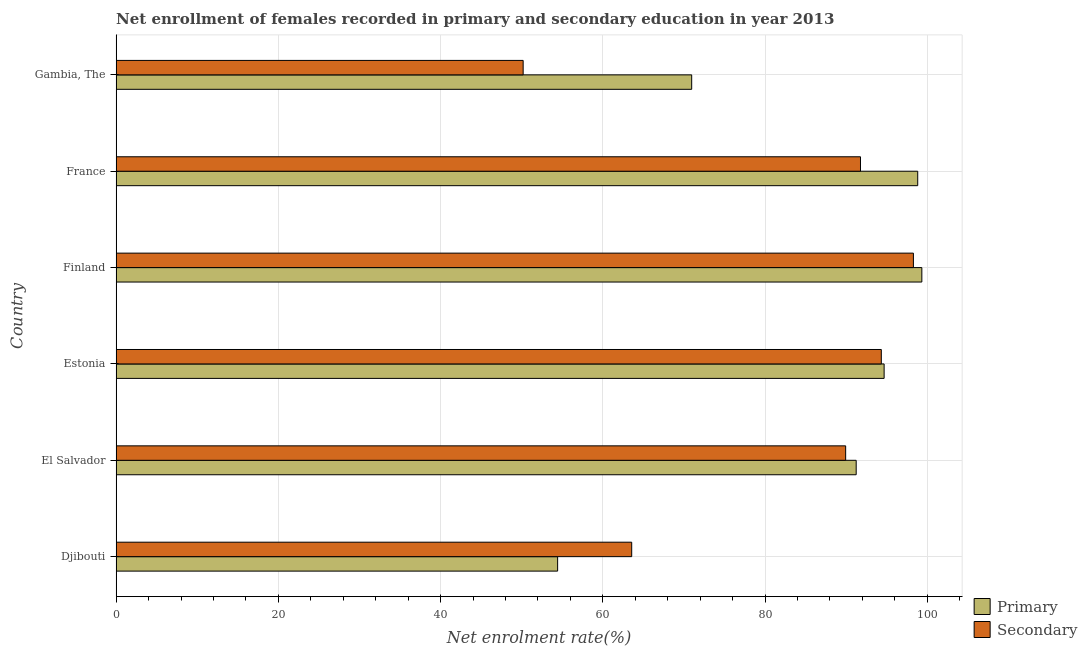What is the label of the 1st group of bars from the top?
Your response must be concise. Gambia, The. What is the enrollment rate in primary education in Gambia, The?
Provide a short and direct response. 70.96. Across all countries, what is the maximum enrollment rate in primary education?
Offer a very short reply. 99.33. Across all countries, what is the minimum enrollment rate in primary education?
Give a very brief answer. 54.43. In which country was the enrollment rate in secondary education minimum?
Offer a very short reply. Gambia, The. What is the total enrollment rate in secondary education in the graph?
Give a very brief answer. 488.07. What is the difference between the enrollment rate in primary education in Djibouti and that in Finland?
Your response must be concise. -44.9. What is the difference between the enrollment rate in primary education in Estonia and the enrollment rate in secondary education in Gambia, The?
Give a very brief answer. 44.5. What is the average enrollment rate in secondary education per country?
Offer a very short reply. 81.34. What is the difference between the enrollment rate in secondary education and enrollment rate in primary education in Gambia, The?
Offer a terse response. -20.78. What is the ratio of the enrollment rate in secondary education in Djibouti to that in Gambia, The?
Provide a short and direct response. 1.27. Is the difference between the enrollment rate in primary education in Estonia and France greater than the difference between the enrollment rate in secondary education in Estonia and France?
Ensure brevity in your answer.  No. What is the difference between the highest and the second highest enrollment rate in primary education?
Offer a very short reply. 0.51. What is the difference between the highest and the lowest enrollment rate in secondary education?
Give a very brief answer. 48.11. What does the 1st bar from the top in Gambia, The represents?
Give a very brief answer. Secondary. What does the 2nd bar from the bottom in France represents?
Ensure brevity in your answer.  Secondary. How many bars are there?
Keep it short and to the point. 12. Are the values on the major ticks of X-axis written in scientific E-notation?
Provide a short and direct response. No. Does the graph contain any zero values?
Offer a terse response. No. How are the legend labels stacked?
Ensure brevity in your answer.  Vertical. What is the title of the graph?
Ensure brevity in your answer.  Net enrollment of females recorded in primary and secondary education in year 2013. What is the label or title of the X-axis?
Make the answer very short. Net enrolment rate(%). What is the Net enrolment rate(%) of Primary in Djibouti?
Make the answer very short. 54.43. What is the Net enrolment rate(%) in Secondary in Djibouti?
Your response must be concise. 63.56. What is the Net enrolment rate(%) of Primary in El Salvador?
Offer a very short reply. 91.24. What is the Net enrolment rate(%) in Secondary in El Salvador?
Offer a very short reply. 89.94. What is the Net enrolment rate(%) in Primary in Estonia?
Make the answer very short. 94.68. What is the Net enrolment rate(%) of Secondary in Estonia?
Keep it short and to the point. 94.33. What is the Net enrolment rate(%) in Primary in Finland?
Provide a succinct answer. 99.33. What is the Net enrolment rate(%) of Secondary in Finland?
Provide a succinct answer. 98.29. What is the Net enrolment rate(%) of Primary in France?
Your response must be concise. 98.82. What is the Net enrolment rate(%) in Secondary in France?
Offer a terse response. 91.77. What is the Net enrolment rate(%) of Primary in Gambia, The?
Make the answer very short. 70.96. What is the Net enrolment rate(%) of Secondary in Gambia, The?
Make the answer very short. 50.18. Across all countries, what is the maximum Net enrolment rate(%) in Primary?
Ensure brevity in your answer.  99.33. Across all countries, what is the maximum Net enrolment rate(%) of Secondary?
Offer a terse response. 98.29. Across all countries, what is the minimum Net enrolment rate(%) of Primary?
Keep it short and to the point. 54.43. Across all countries, what is the minimum Net enrolment rate(%) in Secondary?
Your response must be concise. 50.18. What is the total Net enrolment rate(%) of Primary in the graph?
Ensure brevity in your answer.  509.45. What is the total Net enrolment rate(%) of Secondary in the graph?
Your response must be concise. 488.07. What is the difference between the Net enrolment rate(%) of Primary in Djibouti and that in El Salvador?
Your answer should be very brief. -36.81. What is the difference between the Net enrolment rate(%) in Secondary in Djibouti and that in El Salvador?
Provide a succinct answer. -26.38. What is the difference between the Net enrolment rate(%) in Primary in Djibouti and that in Estonia?
Offer a very short reply. -40.25. What is the difference between the Net enrolment rate(%) of Secondary in Djibouti and that in Estonia?
Ensure brevity in your answer.  -30.77. What is the difference between the Net enrolment rate(%) in Primary in Djibouti and that in Finland?
Offer a terse response. -44.9. What is the difference between the Net enrolment rate(%) of Secondary in Djibouti and that in Finland?
Ensure brevity in your answer.  -34.73. What is the difference between the Net enrolment rate(%) in Primary in Djibouti and that in France?
Offer a very short reply. -44.39. What is the difference between the Net enrolment rate(%) in Secondary in Djibouti and that in France?
Your answer should be compact. -28.2. What is the difference between the Net enrolment rate(%) in Primary in Djibouti and that in Gambia, The?
Your answer should be very brief. -16.53. What is the difference between the Net enrolment rate(%) in Secondary in Djibouti and that in Gambia, The?
Offer a very short reply. 13.38. What is the difference between the Net enrolment rate(%) of Primary in El Salvador and that in Estonia?
Provide a succinct answer. -3.45. What is the difference between the Net enrolment rate(%) in Secondary in El Salvador and that in Estonia?
Keep it short and to the point. -4.4. What is the difference between the Net enrolment rate(%) in Primary in El Salvador and that in Finland?
Give a very brief answer. -8.1. What is the difference between the Net enrolment rate(%) in Secondary in El Salvador and that in Finland?
Offer a very short reply. -8.35. What is the difference between the Net enrolment rate(%) in Primary in El Salvador and that in France?
Ensure brevity in your answer.  -7.59. What is the difference between the Net enrolment rate(%) in Secondary in El Salvador and that in France?
Offer a terse response. -1.83. What is the difference between the Net enrolment rate(%) in Primary in El Salvador and that in Gambia, The?
Provide a short and direct response. 20.28. What is the difference between the Net enrolment rate(%) in Secondary in El Salvador and that in Gambia, The?
Your response must be concise. 39.76. What is the difference between the Net enrolment rate(%) of Primary in Estonia and that in Finland?
Your response must be concise. -4.65. What is the difference between the Net enrolment rate(%) in Secondary in Estonia and that in Finland?
Make the answer very short. -3.96. What is the difference between the Net enrolment rate(%) in Primary in Estonia and that in France?
Make the answer very short. -4.14. What is the difference between the Net enrolment rate(%) of Secondary in Estonia and that in France?
Ensure brevity in your answer.  2.57. What is the difference between the Net enrolment rate(%) in Primary in Estonia and that in Gambia, The?
Make the answer very short. 23.72. What is the difference between the Net enrolment rate(%) in Secondary in Estonia and that in Gambia, The?
Give a very brief answer. 44.16. What is the difference between the Net enrolment rate(%) in Primary in Finland and that in France?
Make the answer very short. 0.51. What is the difference between the Net enrolment rate(%) of Secondary in Finland and that in France?
Offer a very short reply. 6.53. What is the difference between the Net enrolment rate(%) in Primary in Finland and that in Gambia, The?
Ensure brevity in your answer.  28.37. What is the difference between the Net enrolment rate(%) in Secondary in Finland and that in Gambia, The?
Provide a succinct answer. 48.11. What is the difference between the Net enrolment rate(%) in Primary in France and that in Gambia, The?
Provide a short and direct response. 27.87. What is the difference between the Net enrolment rate(%) of Secondary in France and that in Gambia, The?
Provide a short and direct response. 41.59. What is the difference between the Net enrolment rate(%) of Primary in Djibouti and the Net enrolment rate(%) of Secondary in El Salvador?
Give a very brief answer. -35.51. What is the difference between the Net enrolment rate(%) of Primary in Djibouti and the Net enrolment rate(%) of Secondary in Estonia?
Keep it short and to the point. -39.91. What is the difference between the Net enrolment rate(%) of Primary in Djibouti and the Net enrolment rate(%) of Secondary in Finland?
Provide a succinct answer. -43.86. What is the difference between the Net enrolment rate(%) in Primary in Djibouti and the Net enrolment rate(%) in Secondary in France?
Provide a short and direct response. -37.34. What is the difference between the Net enrolment rate(%) of Primary in Djibouti and the Net enrolment rate(%) of Secondary in Gambia, The?
Your response must be concise. 4.25. What is the difference between the Net enrolment rate(%) in Primary in El Salvador and the Net enrolment rate(%) in Secondary in Estonia?
Provide a short and direct response. -3.1. What is the difference between the Net enrolment rate(%) of Primary in El Salvador and the Net enrolment rate(%) of Secondary in Finland?
Provide a short and direct response. -7.06. What is the difference between the Net enrolment rate(%) of Primary in El Salvador and the Net enrolment rate(%) of Secondary in France?
Your answer should be very brief. -0.53. What is the difference between the Net enrolment rate(%) in Primary in El Salvador and the Net enrolment rate(%) in Secondary in Gambia, The?
Provide a short and direct response. 41.06. What is the difference between the Net enrolment rate(%) of Primary in Estonia and the Net enrolment rate(%) of Secondary in Finland?
Provide a succinct answer. -3.61. What is the difference between the Net enrolment rate(%) of Primary in Estonia and the Net enrolment rate(%) of Secondary in France?
Provide a succinct answer. 2.92. What is the difference between the Net enrolment rate(%) of Primary in Estonia and the Net enrolment rate(%) of Secondary in Gambia, The?
Your answer should be compact. 44.5. What is the difference between the Net enrolment rate(%) in Primary in Finland and the Net enrolment rate(%) in Secondary in France?
Keep it short and to the point. 7.57. What is the difference between the Net enrolment rate(%) of Primary in Finland and the Net enrolment rate(%) of Secondary in Gambia, The?
Your response must be concise. 49.15. What is the difference between the Net enrolment rate(%) of Primary in France and the Net enrolment rate(%) of Secondary in Gambia, The?
Your response must be concise. 48.64. What is the average Net enrolment rate(%) in Primary per country?
Provide a succinct answer. 84.91. What is the average Net enrolment rate(%) of Secondary per country?
Your answer should be very brief. 81.34. What is the difference between the Net enrolment rate(%) in Primary and Net enrolment rate(%) in Secondary in Djibouti?
Make the answer very short. -9.13. What is the difference between the Net enrolment rate(%) in Primary and Net enrolment rate(%) in Secondary in El Salvador?
Offer a terse response. 1.3. What is the difference between the Net enrolment rate(%) in Primary and Net enrolment rate(%) in Secondary in Estonia?
Ensure brevity in your answer.  0.35. What is the difference between the Net enrolment rate(%) in Primary and Net enrolment rate(%) in Secondary in Finland?
Give a very brief answer. 1.04. What is the difference between the Net enrolment rate(%) in Primary and Net enrolment rate(%) in Secondary in France?
Offer a terse response. 7.06. What is the difference between the Net enrolment rate(%) in Primary and Net enrolment rate(%) in Secondary in Gambia, The?
Offer a terse response. 20.78. What is the ratio of the Net enrolment rate(%) of Primary in Djibouti to that in El Salvador?
Give a very brief answer. 0.6. What is the ratio of the Net enrolment rate(%) in Secondary in Djibouti to that in El Salvador?
Give a very brief answer. 0.71. What is the ratio of the Net enrolment rate(%) in Primary in Djibouti to that in Estonia?
Keep it short and to the point. 0.57. What is the ratio of the Net enrolment rate(%) of Secondary in Djibouti to that in Estonia?
Ensure brevity in your answer.  0.67. What is the ratio of the Net enrolment rate(%) of Primary in Djibouti to that in Finland?
Make the answer very short. 0.55. What is the ratio of the Net enrolment rate(%) in Secondary in Djibouti to that in Finland?
Ensure brevity in your answer.  0.65. What is the ratio of the Net enrolment rate(%) of Primary in Djibouti to that in France?
Make the answer very short. 0.55. What is the ratio of the Net enrolment rate(%) of Secondary in Djibouti to that in France?
Your response must be concise. 0.69. What is the ratio of the Net enrolment rate(%) in Primary in Djibouti to that in Gambia, The?
Make the answer very short. 0.77. What is the ratio of the Net enrolment rate(%) of Secondary in Djibouti to that in Gambia, The?
Offer a very short reply. 1.27. What is the ratio of the Net enrolment rate(%) of Primary in El Salvador to that in Estonia?
Keep it short and to the point. 0.96. What is the ratio of the Net enrolment rate(%) of Secondary in El Salvador to that in Estonia?
Your answer should be very brief. 0.95. What is the ratio of the Net enrolment rate(%) of Primary in El Salvador to that in Finland?
Keep it short and to the point. 0.92. What is the ratio of the Net enrolment rate(%) in Secondary in El Salvador to that in Finland?
Give a very brief answer. 0.92. What is the ratio of the Net enrolment rate(%) in Primary in El Salvador to that in France?
Give a very brief answer. 0.92. What is the ratio of the Net enrolment rate(%) of Secondary in El Salvador to that in France?
Ensure brevity in your answer.  0.98. What is the ratio of the Net enrolment rate(%) of Primary in El Salvador to that in Gambia, The?
Your answer should be very brief. 1.29. What is the ratio of the Net enrolment rate(%) of Secondary in El Salvador to that in Gambia, The?
Offer a very short reply. 1.79. What is the ratio of the Net enrolment rate(%) of Primary in Estonia to that in Finland?
Give a very brief answer. 0.95. What is the ratio of the Net enrolment rate(%) in Secondary in Estonia to that in Finland?
Your answer should be very brief. 0.96. What is the ratio of the Net enrolment rate(%) in Primary in Estonia to that in France?
Keep it short and to the point. 0.96. What is the ratio of the Net enrolment rate(%) of Secondary in Estonia to that in France?
Provide a succinct answer. 1.03. What is the ratio of the Net enrolment rate(%) of Primary in Estonia to that in Gambia, The?
Your response must be concise. 1.33. What is the ratio of the Net enrolment rate(%) in Secondary in Estonia to that in Gambia, The?
Your response must be concise. 1.88. What is the ratio of the Net enrolment rate(%) of Primary in Finland to that in France?
Your answer should be compact. 1.01. What is the ratio of the Net enrolment rate(%) in Secondary in Finland to that in France?
Keep it short and to the point. 1.07. What is the ratio of the Net enrolment rate(%) in Primary in Finland to that in Gambia, The?
Your answer should be very brief. 1.4. What is the ratio of the Net enrolment rate(%) in Secondary in Finland to that in Gambia, The?
Offer a terse response. 1.96. What is the ratio of the Net enrolment rate(%) in Primary in France to that in Gambia, The?
Your answer should be compact. 1.39. What is the ratio of the Net enrolment rate(%) of Secondary in France to that in Gambia, The?
Offer a terse response. 1.83. What is the difference between the highest and the second highest Net enrolment rate(%) in Primary?
Provide a short and direct response. 0.51. What is the difference between the highest and the second highest Net enrolment rate(%) of Secondary?
Make the answer very short. 3.96. What is the difference between the highest and the lowest Net enrolment rate(%) of Primary?
Offer a very short reply. 44.9. What is the difference between the highest and the lowest Net enrolment rate(%) in Secondary?
Provide a short and direct response. 48.11. 